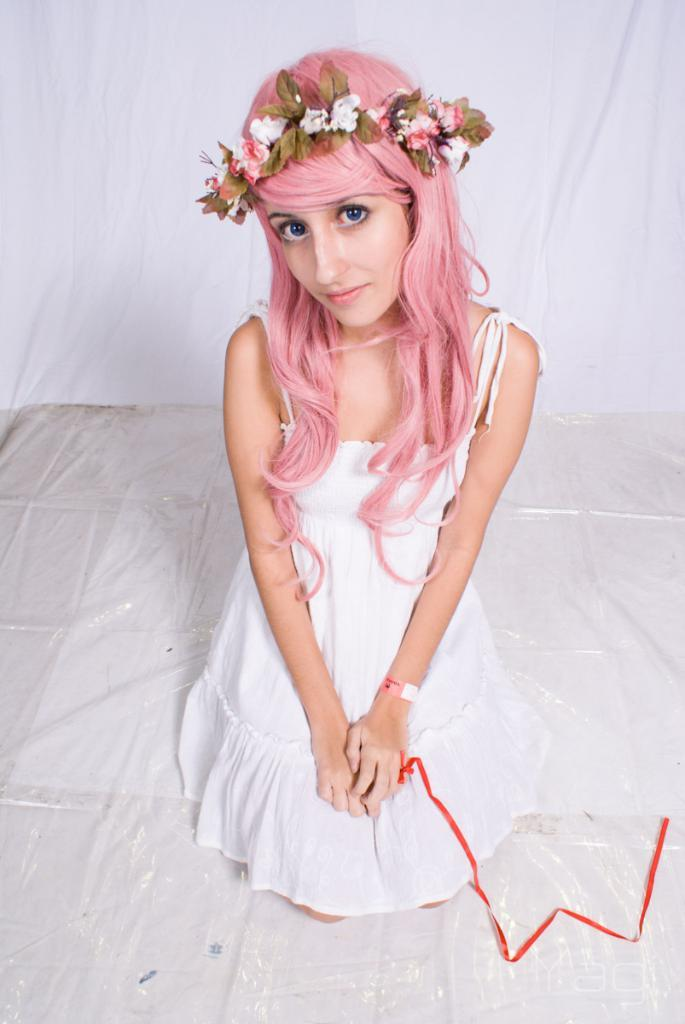Who or what is the main subject in the image? There is a person in the image. Can you describe the position of the person in the image? The person is in front of the image. What is visible behind the person? There is a curtain behind the person. How many kisses can be seen on the person's face in the image? There is no indication of any kisses on the person's face in the image. What type of shop is visible in the background of the image? There is no shop visible in the background of the image; only a curtain is present. 